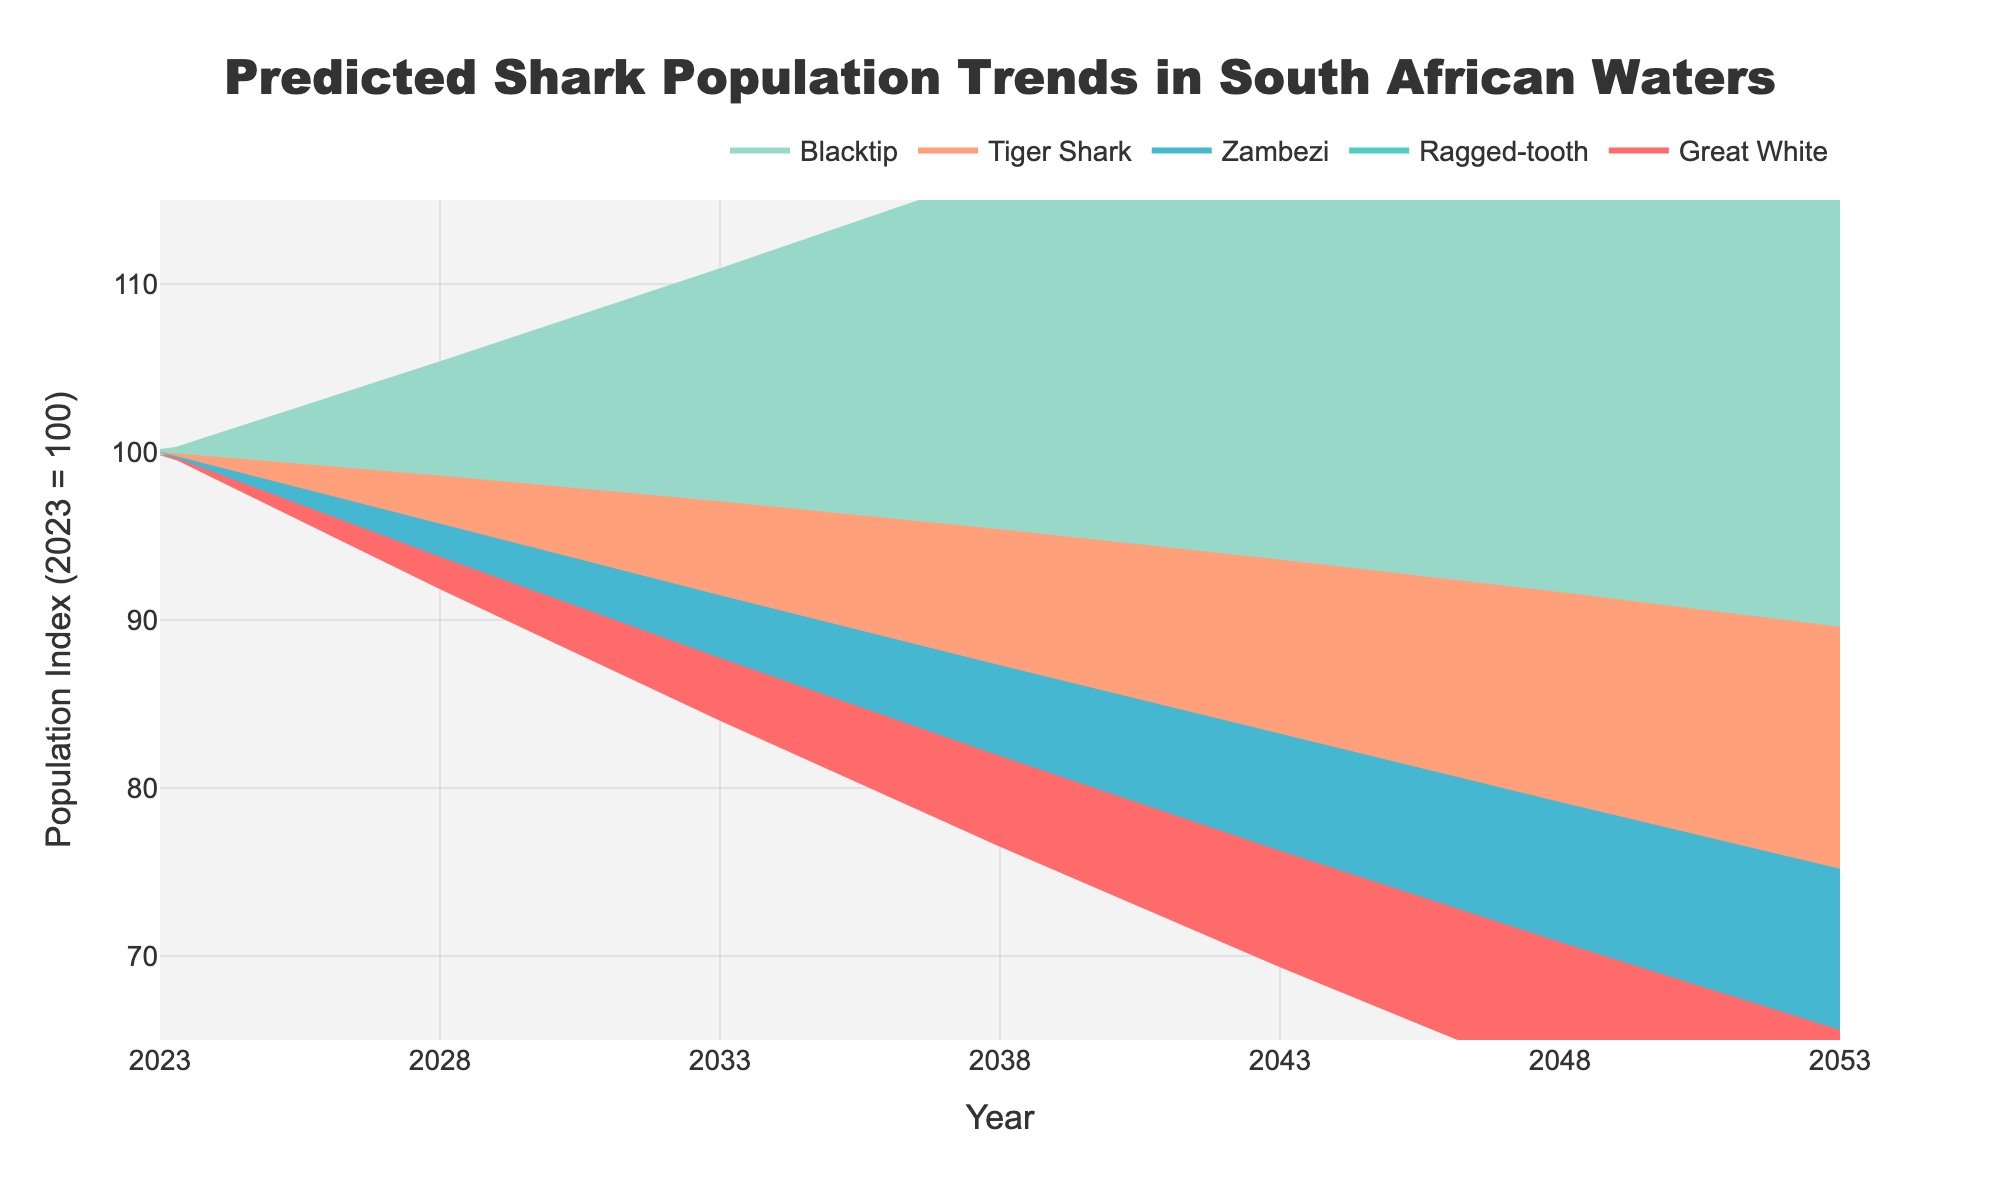what is the title of the figure? The title can be found at the top of the figure. Here, it reads "Predicted Shark Population Trends in South African Waters".
Answer: Predicted Shark Population Trends in South African Waters How many species of sharks are tracked in the figure? Count the number of different lines or check the legend at the top. There are five species.
Answer: Five Which species of shark has the highest predicted population in 2053? By looking at the lines at the far right (2053) of the chart, the line for Blacktip is the highest, indicating it has the highest predicted population.
Answer: Blacktip What is the general trend for the Great White shark population over the next 30 years? Observe the line for the Great White shark from 2023 to 2053. It consistently decreases over time.
Answer: Decreasing By how much is the population of the Great White shark predicted to decline from 2023 to 2053? Subtract the predicted population in 2053 from the population in 2023: 100 - 70 = 30.
Answer: 30 Around which year do the Ragged-tooth and Zambezi sharks have almost equal predicted populations? Observe where the lines for Ragged-tooth and Zambezi sharks are closest. Around 2028, their populations are 98 and 97, which are quite close.
Answer: 2028 Which shark species shows an increasing trend in its population? Identify which line on the chart is sloping upward. The line for Blacktip initially increases from 100 and continues to increase, indicating a rising trend.
Answer: Blacktip What is the population range for Zambezi sharks in 2038 considering the uncertainty band? Observe the upper and lower bounds of the shaded area for Zambezi sharks at 2038. The upper bound is around 91 * 1.1 = 100.1, and the lower bound is around 91 * 0.9 = 81.9.
Answer: 81.9 to 100.1 Compare the populations of Tiger Shark and Blacktip in 2048; which species has a higher population? By looking at the lines for 2048, the line for Blacktip is higher than that for Tiger Shark.
Answer: Blacktip 